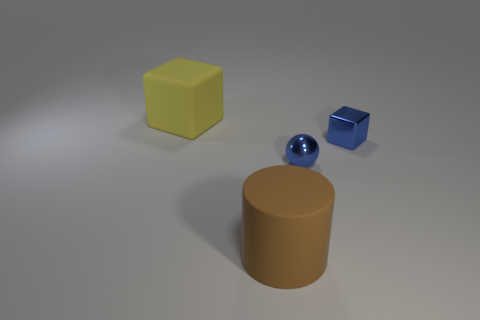What number of tiny blue objects are in front of the tiny cube?
Keep it short and to the point. 1. What is the blue block made of?
Ensure brevity in your answer.  Metal. What color is the big thing that is on the left side of the large brown rubber cylinder that is in front of the big matte object that is behind the blue metallic cube?
Offer a terse response. Yellow. What number of red metallic objects are the same size as the blue sphere?
Your answer should be compact. 0. There is a block right of the large yellow thing; what color is it?
Provide a succinct answer. Blue. What number of other things are the same size as the yellow matte cube?
Keep it short and to the point. 1. What is the size of the thing that is both in front of the shiny block and on the right side of the large rubber cylinder?
Your answer should be compact. Small. There is a small sphere; is it the same color as the shiny thing behind the tiny metallic ball?
Ensure brevity in your answer.  Yes. Is there another thing of the same shape as the brown object?
Ensure brevity in your answer.  No. What number of things are either small blue balls or things behind the small ball?
Your response must be concise. 3. 